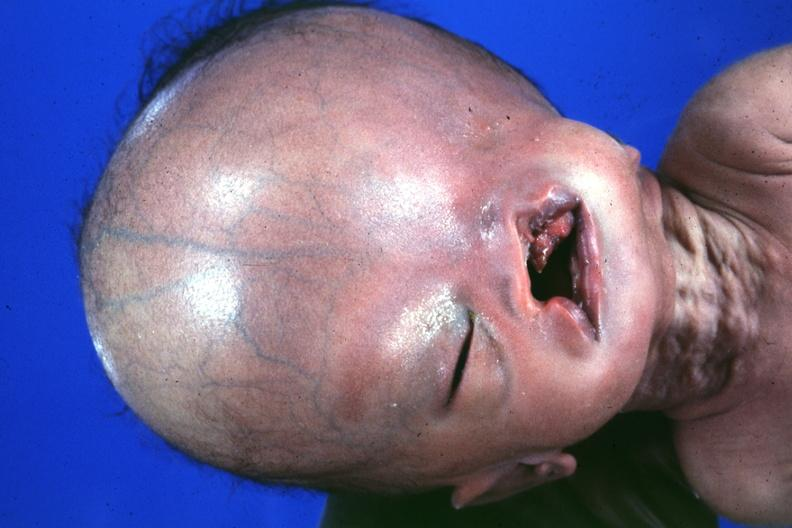what is present?
Answer the question using a single word or phrase. Complex craniofacial abnormalities 